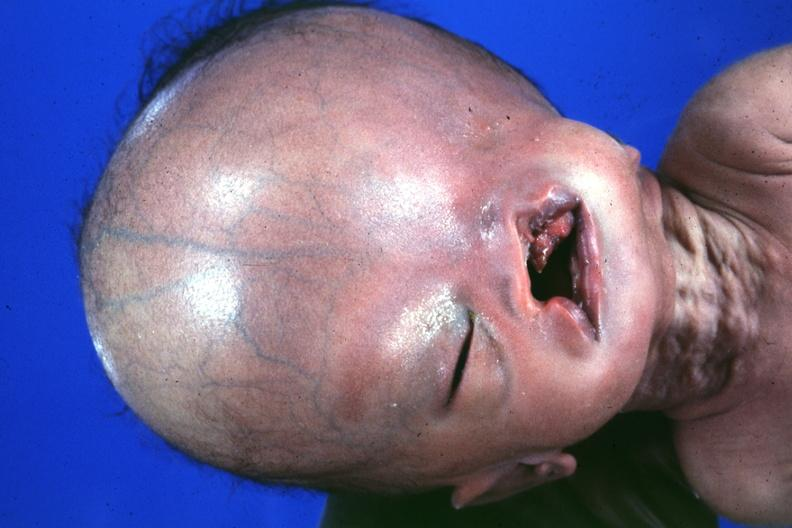what is present?
Answer the question using a single word or phrase. Complex craniofacial abnormalities 